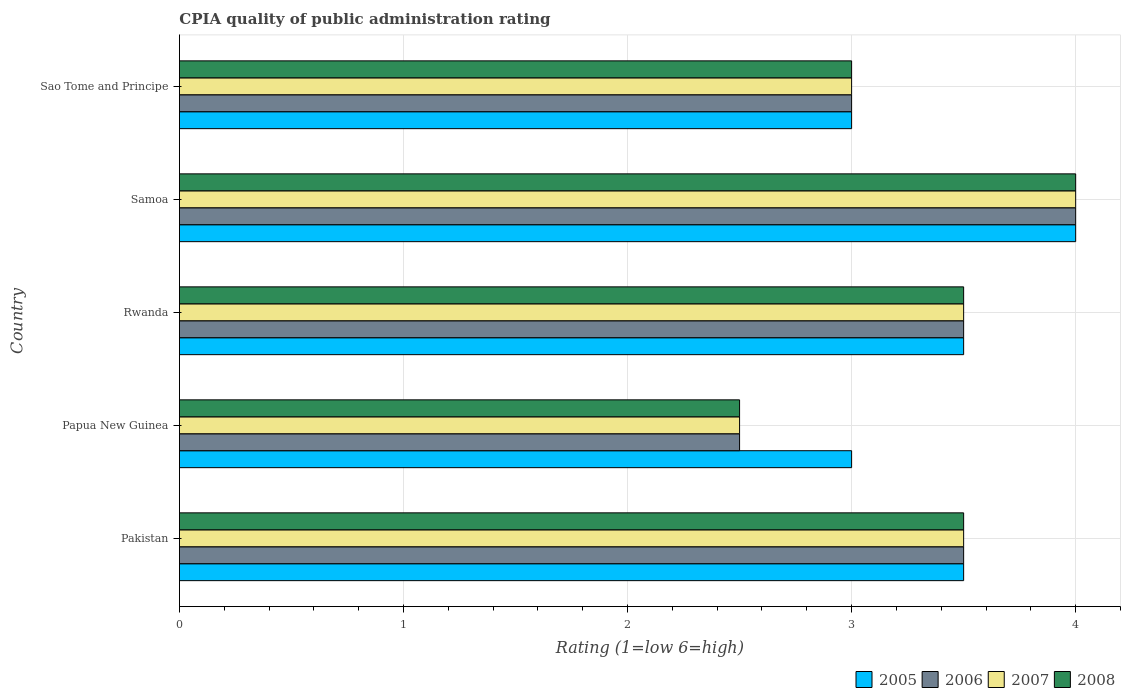Are the number of bars per tick equal to the number of legend labels?
Ensure brevity in your answer.  Yes. Are the number of bars on each tick of the Y-axis equal?
Provide a short and direct response. Yes. How many bars are there on the 2nd tick from the bottom?
Your answer should be compact. 4. What is the CPIA rating in 2006 in Pakistan?
Ensure brevity in your answer.  3.5. Across all countries, what is the minimum CPIA rating in 2007?
Make the answer very short. 2.5. In which country was the CPIA rating in 2008 maximum?
Make the answer very short. Samoa. In which country was the CPIA rating in 2006 minimum?
Ensure brevity in your answer.  Papua New Guinea. What is the total CPIA rating in 2005 in the graph?
Offer a terse response. 17. What is the difference between the CPIA rating in 2006 in Papua New Guinea and that in Samoa?
Offer a terse response. -1.5. What is the difference between the CPIA rating in 2007 and CPIA rating in 2008 in Samoa?
Provide a short and direct response. 0. In how many countries, is the CPIA rating in 2008 greater than 0.4 ?
Give a very brief answer. 5. What is the ratio of the CPIA rating in 2007 in Samoa to that in Sao Tome and Principe?
Offer a terse response. 1.33. Is the CPIA rating in 2006 in Papua New Guinea less than that in Sao Tome and Principe?
Offer a very short reply. Yes. Is the difference between the CPIA rating in 2007 in Papua New Guinea and Rwanda greater than the difference between the CPIA rating in 2008 in Papua New Guinea and Rwanda?
Give a very brief answer. No. What is the difference between the highest and the second highest CPIA rating in 2007?
Keep it short and to the point. 0.5. What is the difference between the highest and the lowest CPIA rating in 2008?
Make the answer very short. 1.5. In how many countries, is the CPIA rating in 2007 greater than the average CPIA rating in 2007 taken over all countries?
Your response must be concise. 3. Is it the case that in every country, the sum of the CPIA rating in 2008 and CPIA rating in 2005 is greater than the sum of CPIA rating in 2006 and CPIA rating in 2007?
Provide a succinct answer. No. Are all the bars in the graph horizontal?
Make the answer very short. Yes. How many countries are there in the graph?
Give a very brief answer. 5. Does the graph contain any zero values?
Make the answer very short. No. Where does the legend appear in the graph?
Your answer should be compact. Bottom right. How are the legend labels stacked?
Your answer should be very brief. Horizontal. What is the title of the graph?
Your response must be concise. CPIA quality of public administration rating. What is the label or title of the X-axis?
Offer a terse response. Rating (1=low 6=high). What is the label or title of the Y-axis?
Provide a short and direct response. Country. What is the Rating (1=low 6=high) of 2007 in Pakistan?
Your response must be concise. 3.5. What is the Rating (1=low 6=high) in 2008 in Pakistan?
Provide a succinct answer. 3.5. What is the Rating (1=low 6=high) in 2007 in Papua New Guinea?
Offer a terse response. 2.5. What is the Rating (1=low 6=high) in 2008 in Papua New Guinea?
Give a very brief answer. 2.5. What is the Rating (1=low 6=high) in 2006 in Samoa?
Provide a short and direct response. 4. What is the Rating (1=low 6=high) in 2008 in Sao Tome and Principe?
Provide a succinct answer. 3. Across all countries, what is the maximum Rating (1=low 6=high) in 2006?
Keep it short and to the point. 4. Across all countries, what is the maximum Rating (1=low 6=high) in 2007?
Your response must be concise. 4. Across all countries, what is the maximum Rating (1=low 6=high) of 2008?
Your response must be concise. 4. Across all countries, what is the minimum Rating (1=low 6=high) in 2005?
Ensure brevity in your answer.  3. Across all countries, what is the minimum Rating (1=low 6=high) of 2006?
Give a very brief answer. 2.5. Across all countries, what is the minimum Rating (1=low 6=high) in 2007?
Your response must be concise. 2.5. What is the total Rating (1=low 6=high) of 2007 in the graph?
Your answer should be compact. 16.5. What is the difference between the Rating (1=low 6=high) of 2008 in Pakistan and that in Rwanda?
Your answer should be compact. 0. What is the difference between the Rating (1=low 6=high) in 2005 in Pakistan and that in Samoa?
Provide a short and direct response. -0.5. What is the difference between the Rating (1=low 6=high) in 2007 in Pakistan and that in Sao Tome and Principe?
Provide a succinct answer. 0.5. What is the difference between the Rating (1=low 6=high) in 2007 in Papua New Guinea and that in Rwanda?
Provide a short and direct response. -1. What is the difference between the Rating (1=low 6=high) in 2005 in Papua New Guinea and that in Samoa?
Offer a very short reply. -1. What is the difference between the Rating (1=low 6=high) of 2006 in Papua New Guinea and that in Samoa?
Provide a succinct answer. -1.5. What is the difference between the Rating (1=low 6=high) of 2005 in Papua New Guinea and that in Sao Tome and Principe?
Make the answer very short. 0. What is the difference between the Rating (1=low 6=high) in 2007 in Papua New Guinea and that in Sao Tome and Principe?
Your answer should be compact. -0.5. What is the difference between the Rating (1=low 6=high) in 2006 in Rwanda and that in Samoa?
Give a very brief answer. -0.5. What is the difference between the Rating (1=low 6=high) of 2005 in Rwanda and that in Sao Tome and Principe?
Keep it short and to the point. 0.5. What is the difference between the Rating (1=low 6=high) in 2008 in Rwanda and that in Sao Tome and Principe?
Your response must be concise. 0.5. What is the difference between the Rating (1=low 6=high) in 2005 in Samoa and that in Sao Tome and Principe?
Provide a succinct answer. 1. What is the difference between the Rating (1=low 6=high) in 2006 in Samoa and that in Sao Tome and Principe?
Your answer should be very brief. 1. What is the difference between the Rating (1=low 6=high) in 2008 in Samoa and that in Sao Tome and Principe?
Ensure brevity in your answer.  1. What is the difference between the Rating (1=low 6=high) of 2005 in Pakistan and the Rating (1=low 6=high) of 2007 in Papua New Guinea?
Ensure brevity in your answer.  1. What is the difference between the Rating (1=low 6=high) in 2005 in Pakistan and the Rating (1=low 6=high) in 2008 in Papua New Guinea?
Give a very brief answer. 1. What is the difference between the Rating (1=low 6=high) of 2006 in Pakistan and the Rating (1=low 6=high) of 2008 in Papua New Guinea?
Your response must be concise. 1. What is the difference between the Rating (1=low 6=high) of 2007 in Pakistan and the Rating (1=low 6=high) of 2008 in Papua New Guinea?
Keep it short and to the point. 1. What is the difference between the Rating (1=low 6=high) of 2005 in Pakistan and the Rating (1=low 6=high) of 2006 in Rwanda?
Your answer should be very brief. 0. What is the difference between the Rating (1=low 6=high) in 2005 in Pakistan and the Rating (1=low 6=high) in 2007 in Rwanda?
Your answer should be very brief. 0. What is the difference between the Rating (1=low 6=high) in 2005 in Pakistan and the Rating (1=low 6=high) in 2008 in Rwanda?
Keep it short and to the point. 0. What is the difference between the Rating (1=low 6=high) of 2006 in Pakistan and the Rating (1=low 6=high) of 2007 in Rwanda?
Provide a succinct answer. 0. What is the difference between the Rating (1=low 6=high) of 2006 in Pakistan and the Rating (1=low 6=high) of 2008 in Rwanda?
Keep it short and to the point. 0. What is the difference between the Rating (1=low 6=high) in 2007 in Pakistan and the Rating (1=low 6=high) in 2008 in Rwanda?
Provide a short and direct response. 0. What is the difference between the Rating (1=low 6=high) of 2005 in Pakistan and the Rating (1=low 6=high) of 2006 in Samoa?
Your answer should be very brief. -0.5. What is the difference between the Rating (1=low 6=high) in 2005 in Pakistan and the Rating (1=low 6=high) in 2007 in Samoa?
Offer a very short reply. -0.5. What is the difference between the Rating (1=low 6=high) in 2005 in Pakistan and the Rating (1=low 6=high) in 2008 in Samoa?
Offer a terse response. -0.5. What is the difference between the Rating (1=low 6=high) of 2006 in Pakistan and the Rating (1=low 6=high) of 2008 in Samoa?
Offer a terse response. -0.5. What is the difference between the Rating (1=low 6=high) of 2007 in Pakistan and the Rating (1=low 6=high) of 2008 in Samoa?
Make the answer very short. -0.5. What is the difference between the Rating (1=low 6=high) in 2005 in Pakistan and the Rating (1=low 6=high) in 2006 in Sao Tome and Principe?
Provide a short and direct response. 0.5. What is the difference between the Rating (1=low 6=high) of 2005 in Pakistan and the Rating (1=low 6=high) of 2007 in Sao Tome and Principe?
Your response must be concise. 0.5. What is the difference between the Rating (1=low 6=high) in 2006 in Pakistan and the Rating (1=low 6=high) in 2008 in Sao Tome and Principe?
Keep it short and to the point. 0.5. What is the difference between the Rating (1=low 6=high) of 2005 in Papua New Guinea and the Rating (1=low 6=high) of 2007 in Rwanda?
Offer a very short reply. -0.5. What is the difference between the Rating (1=low 6=high) in 2006 in Papua New Guinea and the Rating (1=low 6=high) in 2008 in Rwanda?
Offer a terse response. -1. What is the difference between the Rating (1=low 6=high) in 2005 in Papua New Guinea and the Rating (1=low 6=high) in 2006 in Samoa?
Your response must be concise. -1. What is the difference between the Rating (1=low 6=high) in 2005 in Papua New Guinea and the Rating (1=low 6=high) in 2007 in Samoa?
Ensure brevity in your answer.  -1. What is the difference between the Rating (1=low 6=high) of 2005 in Papua New Guinea and the Rating (1=low 6=high) of 2008 in Samoa?
Provide a succinct answer. -1. What is the difference between the Rating (1=low 6=high) of 2007 in Papua New Guinea and the Rating (1=low 6=high) of 2008 in Samoa?
Make the answer very short. -1.5. What is the difference between the Rating (1=low 6=high) of 2005 in Papua New Guinea and the Rating (1=low 6=high) of 2006 in Sao Tome and Principe?
Give a very brief answer. 0. What is the difference between the Rating (1=low 6=high) of 2005 in Papua New Guinea and the Rating (1=low 6=high) of 2007 in Sao Tome and Principe?
Keep it short and to the point. 0. What is the difference between the Rating (1=low 6=high) in 2006 in Papua New Guinea and the Rating (1=low 6=high) in 2008 in Sao Tome and Principe?
Your answer should be very brief. -0.5. What is the difference between the Rating (1=low 6=high) of 2007 in Papua New Guinea and the Rating (1=low 6=high) of 2008 in Sao Tome and Principe?
Make the answer very short. -0.5. What is the difference between the Rating (1=low 6=high) in 2005 in Rwanda and the Rating (1=low 6=high) in 2008 in Samoa?
Offer a terse response. -0.5. What is the difference between the Rating (1=low 6=high) in 2007 in Rwanda and the Rating (1=low 6=high) in 2008 in Samoa?
Your answer should be compact. -0.5. What is the difference between the Rating (1=low 6=high) of 2005 in Rwanda and the Rating (1=low 6=high) of 2006 in Sao Tome and Principe?
Provide a short and direct response. 0.5. What is the difference between the Rating (1=low 6=high) in 2006 in Rwanda and the Rating (1=low 6=high) in 2007 in Sao Tome and Principe?
Make the answer very short. 0.5. What is the difference between the Rating (1=low 6=high) of 2007 in Rwanda and the Rating (1=low 6=high) of 2008 in Sao Tome and Principe?
Offer a very short reply. 0.5. What is the difference between the Rating (1=low 6=high) of 2005 in Samoa and the Rating (1=low 6=high) of 2006 in Sao Tome and Principe?
Keep it short and to the point. 1. What is the difference between the Rating (1=low 6=high) of 2005 in Samoa and the Rating (1=low 6=high) of 2007 in Sao Tome and Principe?
Keep it short and to the point. 1. What is the difference between the Rating (1=low 6=high) in 2006 in Samoa and the Rating (1=low 6=high) in 2008 in Sao Tome and Principe?
Provide a succinct answer. 1. What is the difference between the Rating (1=low 6=high) in 2007 in Samoa and the Rating (1=low 6=high) in 2008 in Sao Tome and Principe?
Ensure brevity in your answer.  1. What is the difference between the Rating (1=low 6=high) of 2006 and Rating (1=low 6=high) of 2007 in Pakistan?
Provide a succinct answer. 0. What is the difference between the Rating (1=low 6=high) in 2006 and Rating (1=low 6=high) in 2008 in Pakistan?
Ensure brevity in your answer.  0. What is the difference between the Rating (1=low 6=high) of 2006 and Rating (1=low 6=high) of 2008 in Papua New Guinea?
Ensure brevity in your answer.  0. What is the difference between the Rating (1=low 6=high) of 2005 and Rating (1=low 6=high) of 2006 in Rwanda?
Make the answer very short. 0. What is the difference between the Rating (1=low 6=high) in 2005 and Rating (1=low 6=high) in 2007 in Rwanda?
Give a very brief answer. 0. What is the difference between the Rating (1=low 6=high) in 2005 and Rating (1=low 6=high) in 2008 in Rwanda?
Make the answer very short. 0. What is the difference between the Rating (1=low 6=high) of 2007 and Rating (1=low 6=high) of 2008 in Rwanda?
Ensure brevity in your answer.  0. What is the difference between the Rating (1=low 6=high) of 2005 and Rating (1=low 6=high) of 2006 in Samoa?
Your answer should be very brief. 0. What is the difference between the Rating (1=low 6=high) in 2005 and Rating (1=low 6=high) in 2006 in Sao Tome and Principe?
Your answer should be very brief. 0. What is the difference between the Rating (1=low 6=high) in 2005 and Rating (1=low 6=high) in 2007 in Sao Tome and Principe?
Offer a very short reply. 0. What is the difference between the Rating (1=low 6=high) in 2007 and Rating (1=low 6=high) in 2008 in Sao Tome and Principe?
Your answer should be very brief. 0. What is the ratio of the Rating (1=low 6=high) in 2005 in Pakistan to that in Papua New Guinea?
Offer a very short reply. 1.17. What is the ratio of the Rating (1=low 6=high) in 2008 in Pakistan to that in Papua New Guinea?
Give a very brief answer. 1.4. What is the ratio of the Rating (1=low 6=high) in 2007 in Pakistan to that in Rwanda?
Provide a succinct answer. 1. What is the ratio of the Rating (1=low 6=high) in 2008 in Pakistan to that in Rwanda?
Provide a short and direct response. 1. What is the ratio of the Rating (1=low 6=high) of 2005 in Pakistan to that in Samoa?
Offer a terse response. 0.88. What is the ratio of the Rating (1=low 6=high) in 2006 in Pakistan to that in Samoa?
Ensure brevity in your answer.  0.88. What is the ratio of the Rating (1=low 6=high) in 2007 in Pakistan to that in Samoa?
Offer a terse response. 0.88. What is the ratio of the Rating (1=low 6=high) of 2008 in Pakistan to that in Sao Tome and Principe?
Give a very brief answer. 1.17. What is the ratio of the Rating (1=low 6=high) in 2006 in Papua New Guinea to that in Samoa?
Provide a short and direct response. 0.62. What is the ratio of the Rating (1=low 6=high) in 2008 in Papua New Guinea to that in Samoa?
Ensure brevity in your answer.  0.62. What is the ratio of the Rating (1=low 6=high) of 2006 in Papua New Guinea to that in Sao Tome and Principe?
Provide a short and direct response. 0.83. What is the ratio of the Rating (1=low 6=high) of 2007 in Papua New Guinea to that in Sao Tome and Principe?
Give a very brief answer. 0.83. What is the ratio of the Rating (1=low 6=high) of 2008 in Papua New Guinea to that in Sao Tome and Principe?
Provide a short and direct response. 0.83. What is the ratio of the Rating (1=low 6=high) in 2005 in Rwanda to that in Sao Tome and Principe?
Your answer should be compact. 1.17. What is the ratio of the Rating (1=low 6=high) in 2006 in Rwanda to that in Sao Tome and Principe?
Make the answer very short. 1.17. What is the ratio of the Rating (1=low 6=high) in 2005 in Samoa to that in Sao Tome and Principe?
Make the answer very short. 1.33. What is the ratio of the Rating (1=low 6=high) of 2007 in Samoa to that in Sao Tome and Principe?
Keep it short and to the point. 1.33. What is the ratio of the Rating (1=low 6=high) of 2008 in Samoa to that in Sao Tome and Principe?
Offer a terse response. 1.33. What is the difference between the highest and the lowest Rating (1=low 6=high) of 2006?
Make the answer very short. 1.5. 